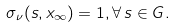Convert formula to latex. <formula><loc_0><loc_0><loc_500><loc_500>\sigma _ { \nu } ( s , x _ { \infty } ) = 1 , \forall \, s \in G .</formula> 